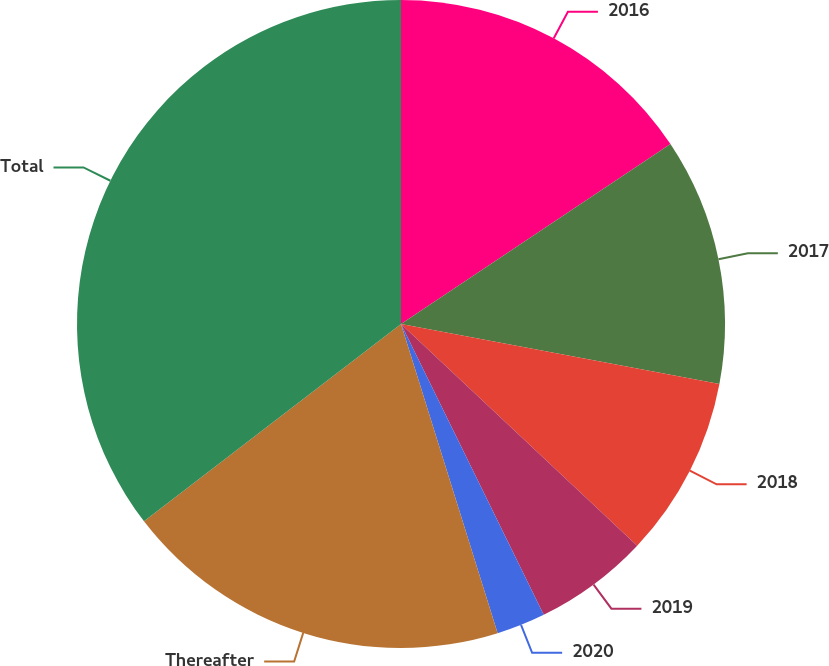Convert chart to OTSL. <chart><loc_0><loc_0><loc_500><loc_500><pie_chart><fcel>2016<fcel>2017<fcel>2018<fcel>2019<fcel>2020<fcel>Thereafter<fcel>Total<nl><fcel>15.63%<fcel>12.33%<fcel>9.04%<fcel>5.74%<fcel>2.44%<fcel>19.4%<fcel>35.42%<nl></chart> 